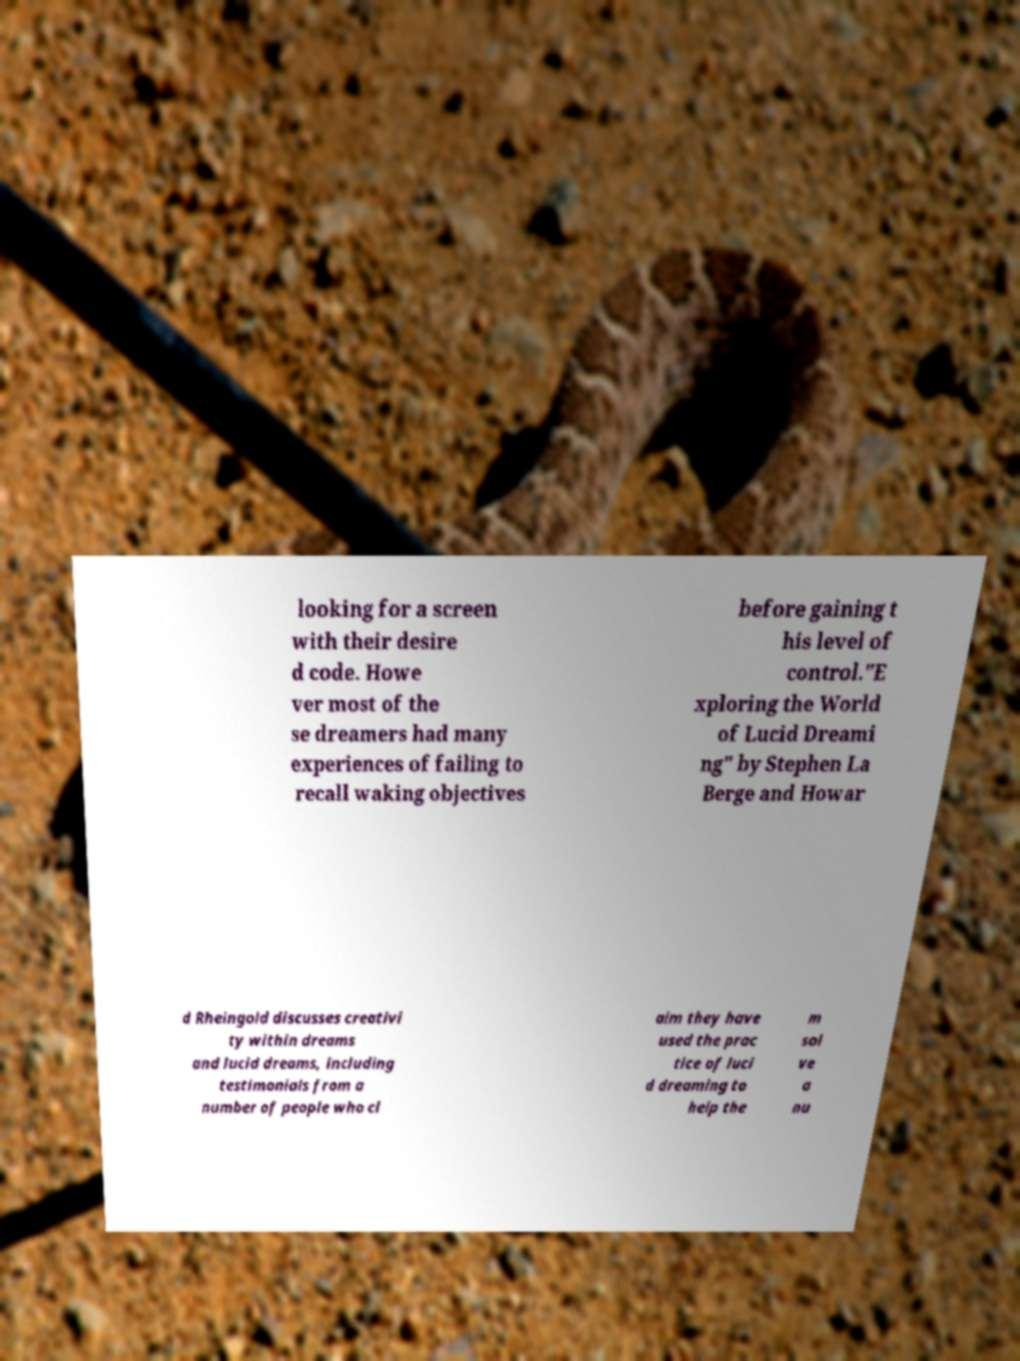There's text embedded in this image that I need extracted. Can you transcribe it verbatim? looking for a screen with their desire d code. Howe ver most of the se dreamers had many experiences of failing to recall waking objectives before gaining t his level of control."E xploring the World of Lucid Dreami ng" by Stephen La Berge and Howar d Rheingold discusses creativi ty within dreams and lucid dreams, including testimonials from a number of people who cl aim they have used the prac tice of luci d dreaming to help the m sol ve a nu 